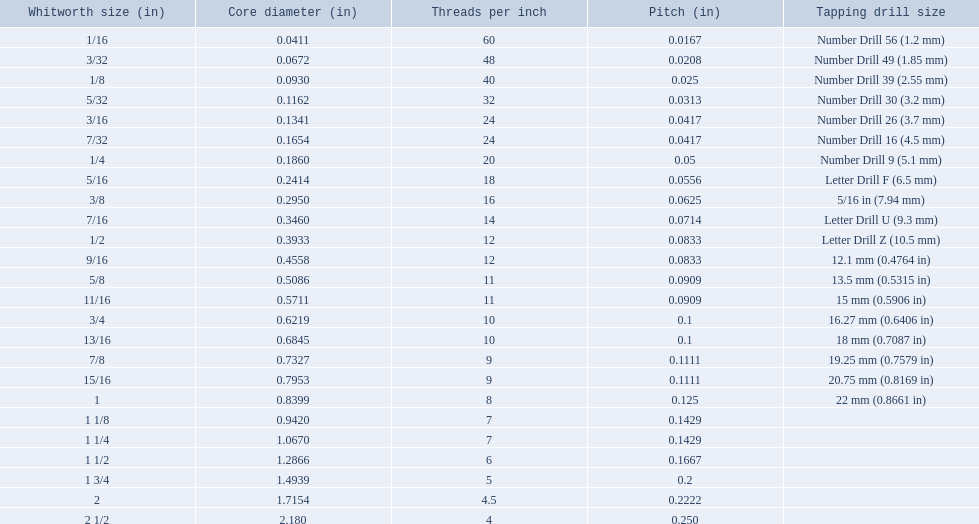What are the whitworth sizes? 1/16, 3/32, 1/8, 5/32, 3/16, 7/32, 1/4, 5/16, 3/8, 7/16, 1/2, 9/16, 5/8, 11/16, 3/4, 13/16, 7/8, 15/16, 1, 1 1/8, 1 1/4, 1 1/2, 1 3/4, 2, 2 1/2. And their threads per inch? 60, 48, 40, 32, 24, 24, 20, 18, 16, 14, 12, 12, 11, 11, 10, 10, 9, 9, 8, 7, 7, 6, 5, 4.5, 4. Now, which whitworth size has a thread-per-inch size of 5?? 1 3/4. What are the whitworth scale sizes? 1/16, 3/32, 1/8, 5/32, 3/16, 7/32, 1/4, 5/16, 3/8, 7/16, 1/2, 9/16, 5/8, 11/16, 3/4, 13/16, 7/8, 15/16, 1, 1 1/8, 1 1/4, 1 1/2, 1 3/4, 2, 2 1/2. And their threads per inch? 60, 48, 40, 32, 24, 24, 20, 18, 16, 14, 12, 12, 11, 11, 10, 10, 9, 9, 8, 7, 7, 6, 5, 4.5, 4. Now, which whitworth scale size has a thread-per-inch value of 5? 1 3/4. In inches, what are the common whitworth measurements? 1/16, 3/32, 1/8, 5/32, 3/16, 7/32, 1/4, 5/16, 3/8, 7/16, 1/2, 9/16, 5/8, 11/16, 3/4, 13/16, 7/8, 15/16, 1, 1 1/8, 1 1/4, 1 1/2, 1 3/4, 2, 2 1/2. What is the thread count per inch for the 3/16 size? 24. Which size (in inches) shares the same number of threads per inch? 7/32. What is the core diameter of a 1/16 whitworth? 0.0411. Which whitworth size shares the same pitch as a 1/2? 9/16. What has the same number of threads as a 3/16 whitworth? 7/32. Would you mind parsing the complete table? {'header': ['Whitworth size (in)', 'Core diameter (in)', 'Threads per\xa0inch', 'Pitch (in)', 'Tapping drill size'], 'rows': [['1/16', '0.0411', '60', '0.0167', 'Number Drill 56 (1.2\xa0mm)'], ['3/32', '0.0672', '48', '0.0208', 'Number Drill 49 (1.85\xa0mm)'], ['1/8', '0.0930', '40', '0.025', 'Number Drill 39 (2.55\xa0mm)'], ['5/32', '0.1162', '32', '0.0313', 'Number Drill 30 (3.2\xa0mm)'], ['3/16', '0.1341', '24', '0.0417', 'Number Drill 26 (3.7\xa0mm)'], ['7/32', '0.1654', '24', '0.0417', 'Number Drill 16 (4.5\xa0mm)'], ['1/4', '0.1860', '20', '0.05', 'Number Drill 9 (5.1\xa0mm)'], ['5/16', '0.2414', '18', '0.0556', 'Letter Drill F (6.5\xa0mm)'], ['3/8', '0.2950', '16', '0.0625', '5/16\xa0in (7.94\xa0mm)'], ['7/16', '0.3460', '14', '0.0714', 'Letter Drill U (9.3\xa0mm)'], ['1/2', '0.3933', '12', '0.0833', 'Letter Drill Z (10.5\xa0mm)'], ['9/16', '0.4558', '12', '0.0833', '12.1\xa0mm (0.4764\xa0in)'], ['5/8', '0.5086', '11', '0.0909', '13.5\xa0mm (0.5315\xa0in)'], ['11/16', '0.5711', '11', '0.0909', '15\xa0mm (0.5906\xa0in)'], ['3/4', '0.6219', '10', '0.1', '16.27\xa0mm (0.6406\xa0in)'], ['13/16', '0.6845', '10', '0.1', '18\xa0mm (0.7087\xa0in)'], ['7/8', '0.7327', '9', '0.1111', '19.25\xa0mm (0.7579\xa0in)'], ['15/16', '0.7953', '9', '0.1111', '20.75\xa0mm (0.8169\xa0in)'], ['1', '0.8399', '8', '0.125', '22\xa0mm (0.8661\xa0in)'], ['1 1/8', '0.9420', '7', '0.1429', ''], ['1 1/4', '1.0670', '7', '0.1429', ''], ['1 1/2', '1.2866', '6', '0.1667', ''], ['1 3/4', '1.4939', '5', '0.2', ''], ['2', '1.7154', '4.5', '0.2222', ''], ['2 1/2', '2.180', '4', '0.250', '']]} 